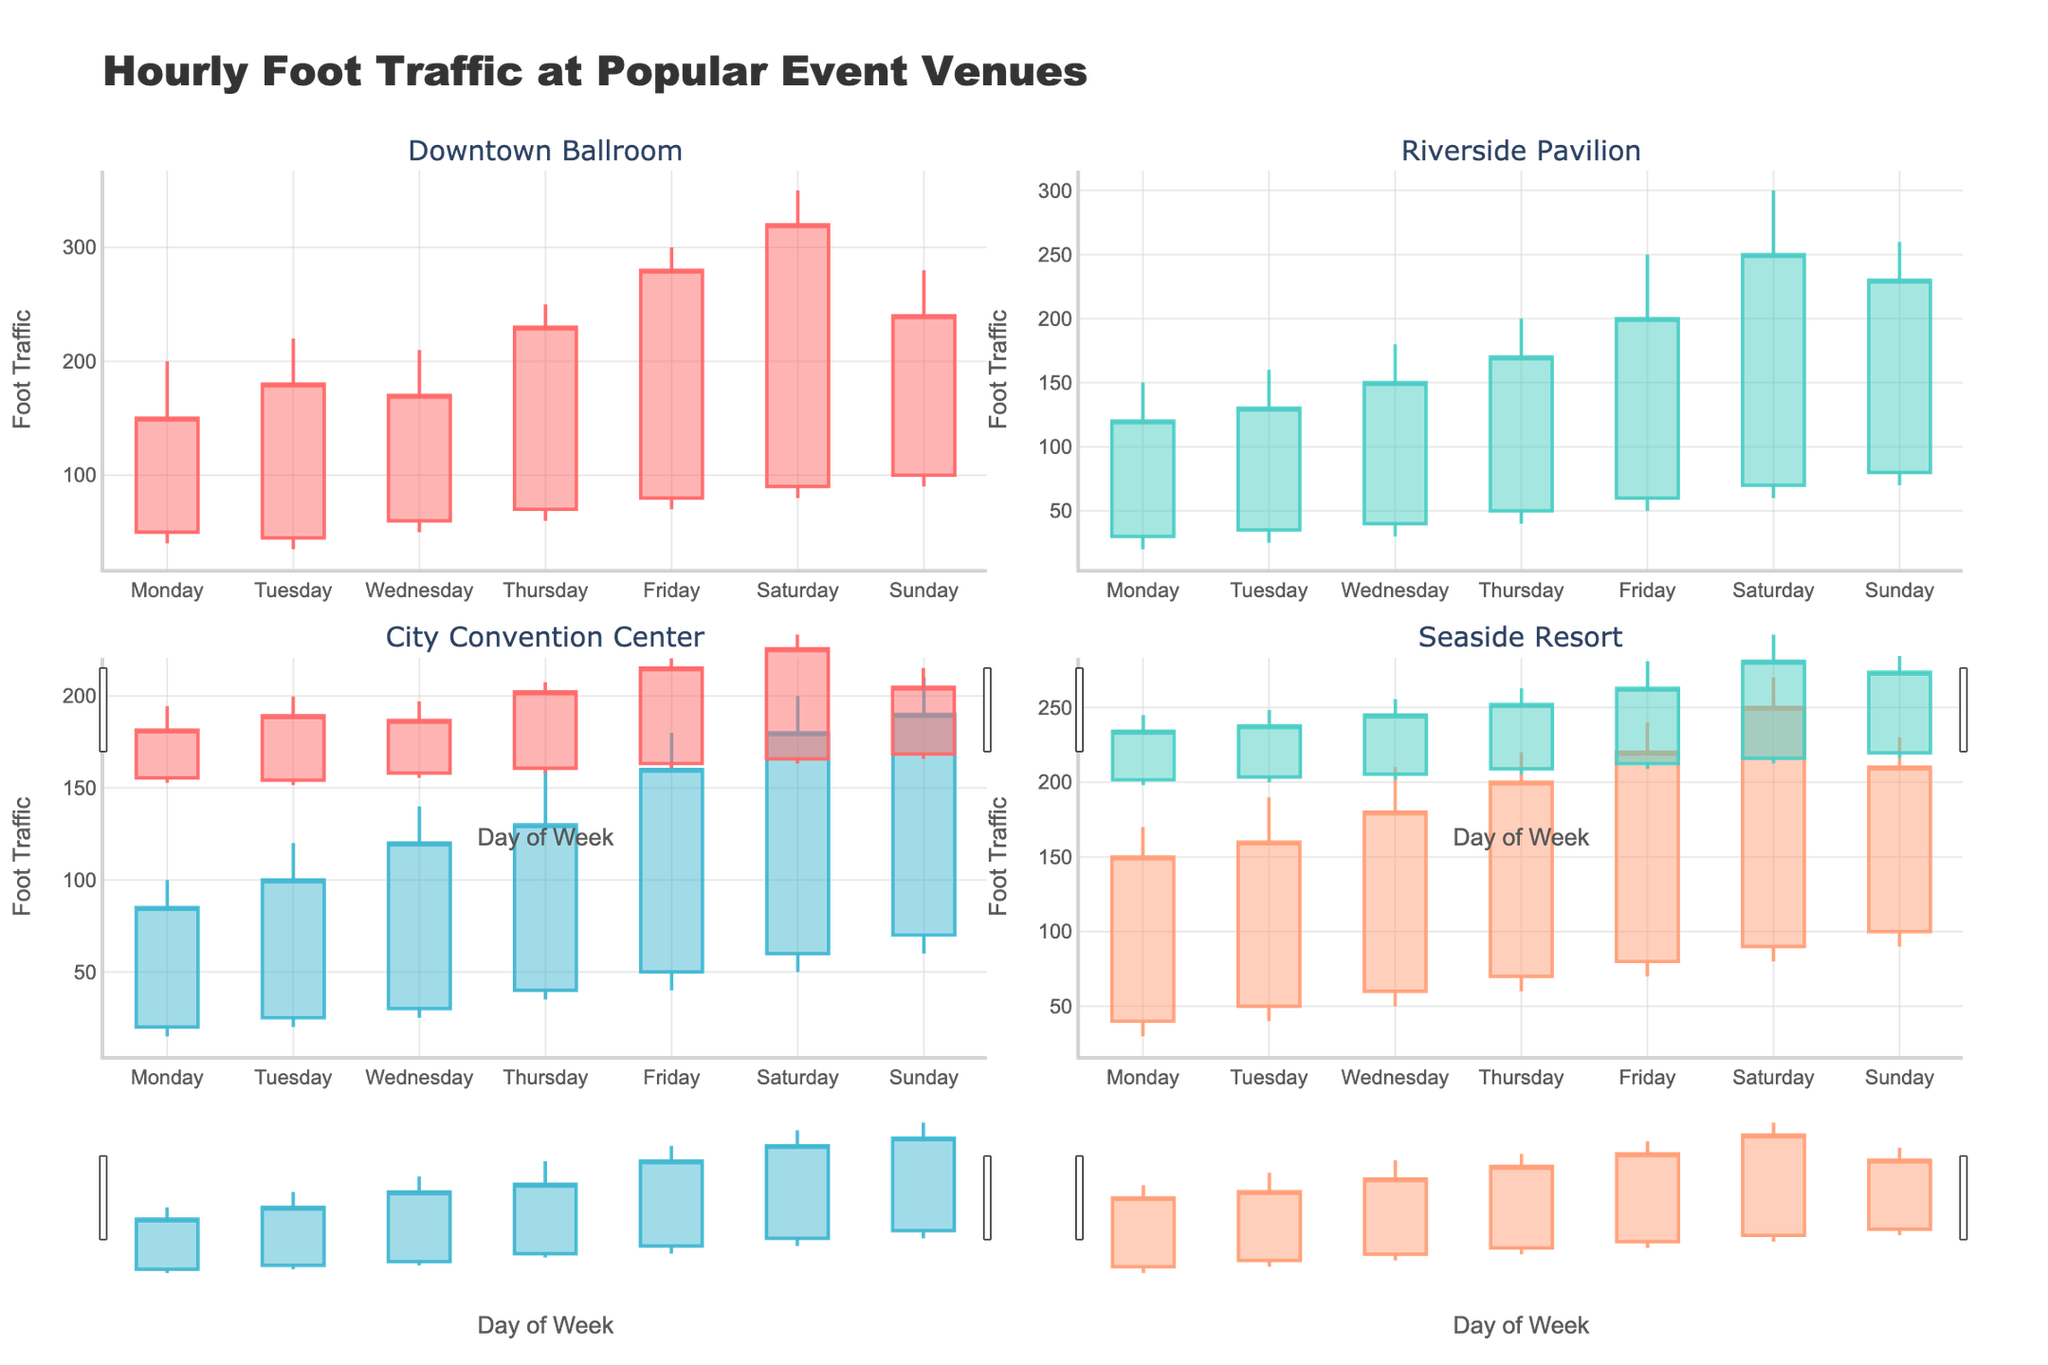Which venue has the highest foot traffic on Friday? To determine this, look at the Friday data across all four venues: Downtown Ballroom (300), Riverside Pavilion (250), City Convention Center (180), and Seaside Resort (240). The highest value is for Downtown Ballroom at 300.
Answer: Downtown Ballroom What is the title of the chart? The title is prominently displayed at the top of the chart and provides an overview of the data being visualized.
Answer: Hourly Foot Traffic at Popular Event Venues What is the range of foot traffic at Riverside Pavilion on Sunday? To find the range, subtract the lowest value from the highest value for Riverside Pavilion on Sunday. The high is 260 and the low is 70, thus the range is 260 - 70.
Answer: 190 Which day has the lowest foot traffic at the City Convention Center? Look at the low values for each day at the City Convention Center: Monday (15), Tuesday (20), Wednesday (25), Thursday (35), Friday (40), Saturday (50), Sunday (60). Monday has the lowest value of 15.
Answer: Monday Compare the increase in foot traffic from open to close on Monday between Downtown Ballroom and Seaside Resort. For Downtown Ballroom, the foot traffic increases from 50 to 150 (150 - 50 = 100). For Seaside Resort, it increases from 40 to 150 (150 - 40 = 110). Hence, Seaside Resort sees a larger increase of 110 compared to Downtown Ballroom's 100.
Answer: Seaside Resort What is the average high foot traffic at Seaside Resort from Monday to Wednesday? Look at the high values for Seaside Resort: Monday (170), Tuesday (190), Wednesday (210). The sum is 570, and there are 3 data points, so the average is 570/3.
Answer: 190 Which venue shows the highest variability in foot traffic on Saturday? Variability can be inferred from the difference between high and low values on Saturday. Downtown Ballroom (350 - 80 = 270), Riverside Pavilion (300 - 60 = 240), City Convention Center (200 - 50 = 150), Seaside Resort (270 - 80 = 190). Downtown Ballroom has the highest difference of 270.
Answer: Downtown Ballroom On which day does Downtown Ballroom have both the highest high and highest close foot traffic? Check the high and close values for Downtown Ballroom for each day: Friday has the highest high (300) and the highest close (280).
Answer: Friday What is the median low foot traffic value for the Riverside Pavilion over the week? Collect the low values for Riverside Pavilion for all days: [20, 25, 30, 40, 50, 60, 70]. To find the median, arrange them in order and identify the middle value. The middle value (4th) is 40.
Answer: 40 